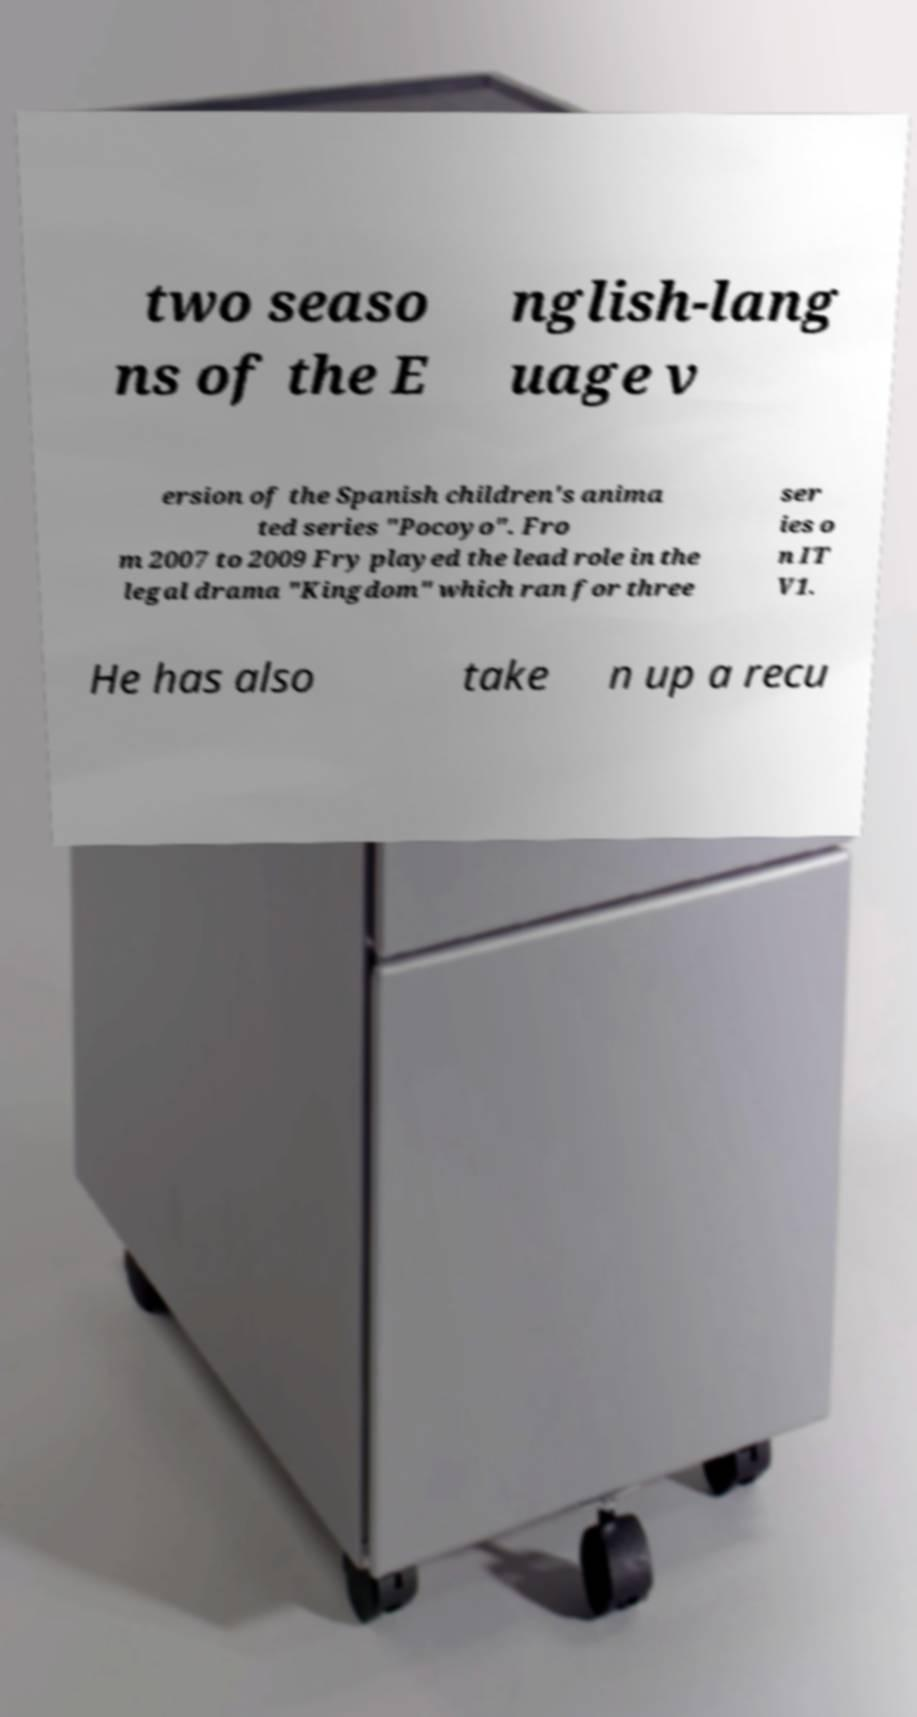Could you assist in decoding the text presented in this image and type it out clearly? two seaso ns of the E nglish-lang uage v ersion of the Spanish children's anima ted series "Pocoyo". Fro m 2007 to 2009 Fry played the lead role in the legal drama "Kingdom" which ran for three ser ies o n IT V1. He has also take n up a recu 